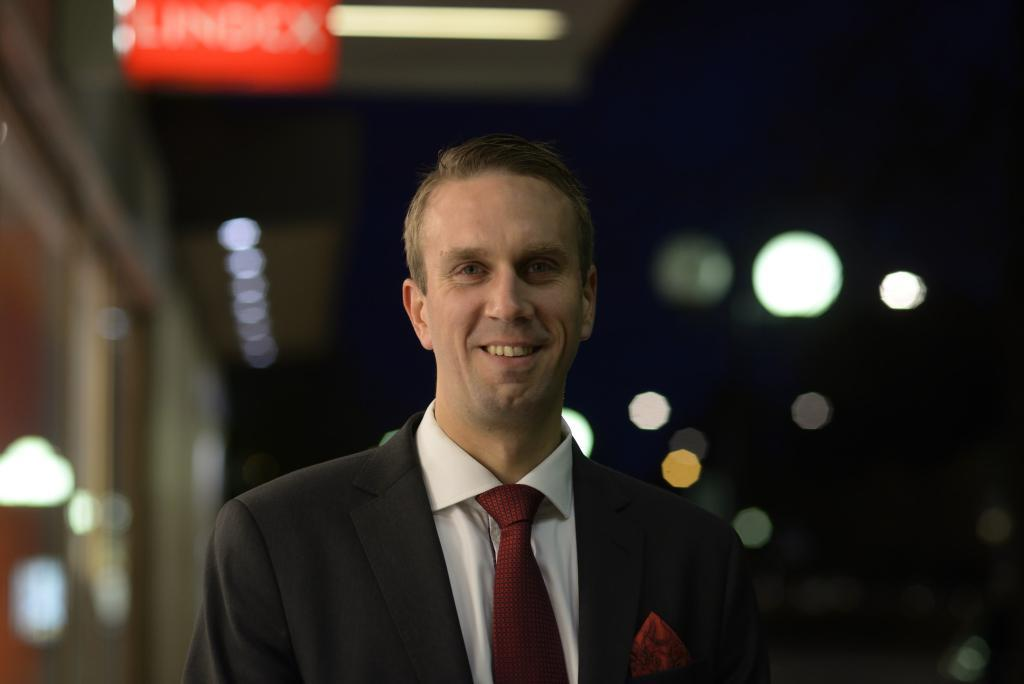What is the main subject of the image? The main subject of the image is a man. What type of clothing is the man wearing? The man is wearing a blazer, a shirt, and a tie. What is the man's facial expression in the image? The man is smiling in the image. What can be seen in the background of the image? The background of the image is blurred. What type of balloon can be seen floating in the background of the image? There is no balloon present in the image; the background is blurred. What smell can be detected from the man's tie in the image? There is no information about the smell of the man's tie in the image. 